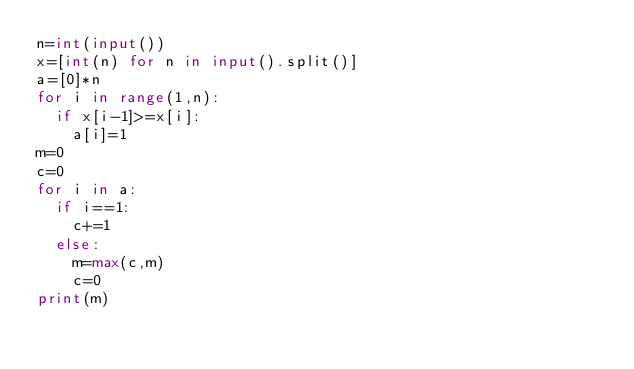Convert code to text. <code><loc_0><loc_0><loc_500><loc_500><_Python_>n=int(input())
x=[int(n) for n in input().split()]
a=[0]*n
for i in range(1,n):
  if x[i-1]>=x[i]:
    a[i]=1
m=0
c=0
for i in a:
  if i==1:
    c+=1
  else:
    m=max(c,m)
    c=0
print(m)</code> 